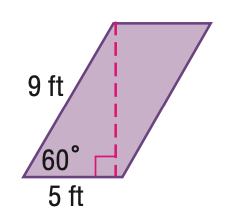Question: Find the perimeter of the parallelogram. Round to the nearest tenth if necessary.
Choices:
A. 14
B. 20
C. 28
D. 36
Answer with the letter. Answer: C Question: Find the area of the parallelogram. Round to the nearest tenth if necessary.
Choices:
A. 25
B. 39.0
C. 43.3
D. 45
Answer with the letter. Answer: B 